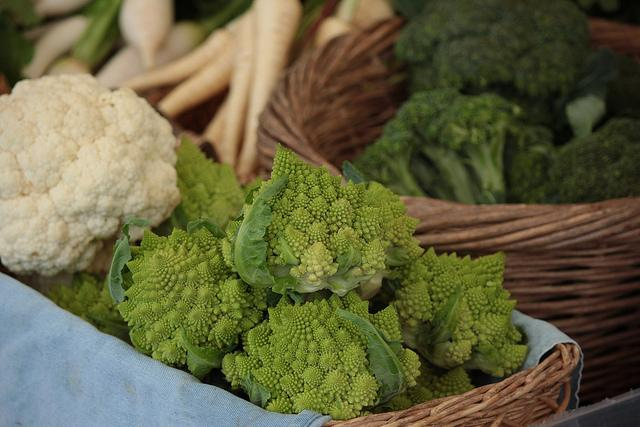What is the more realistic setting for these baskets of food items? Please explain your reasoning. farmer's market. The items are vegetables and would be at place at a farmer's market where they would be sold locally and in fresh condition. 